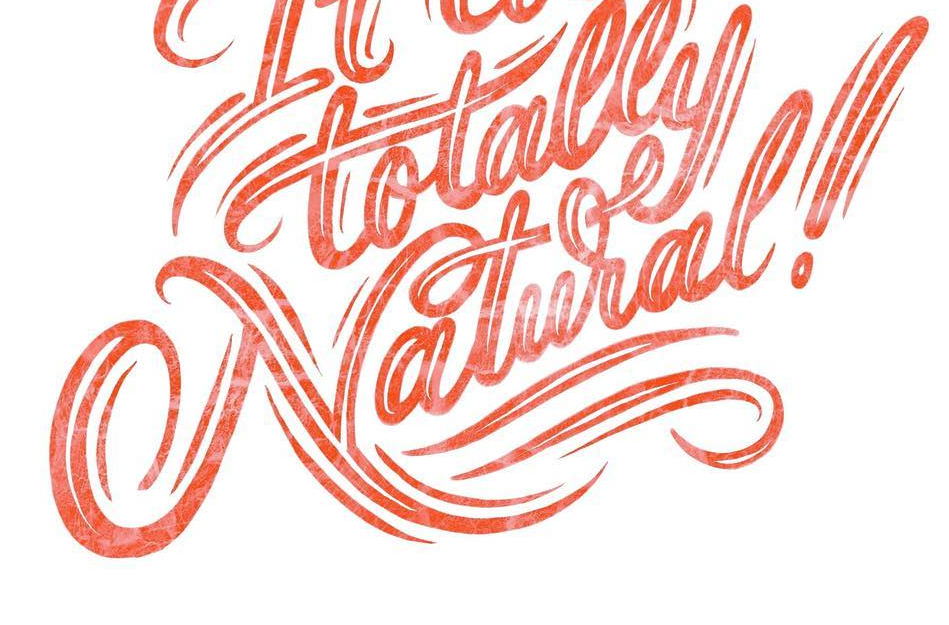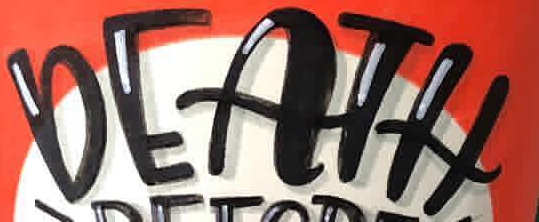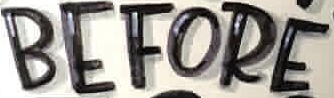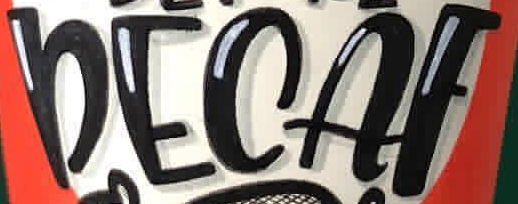Transcribe the words shown in these images in order, separated by a semicolon. Natural!; DEATH; BEFORE; DECAF 